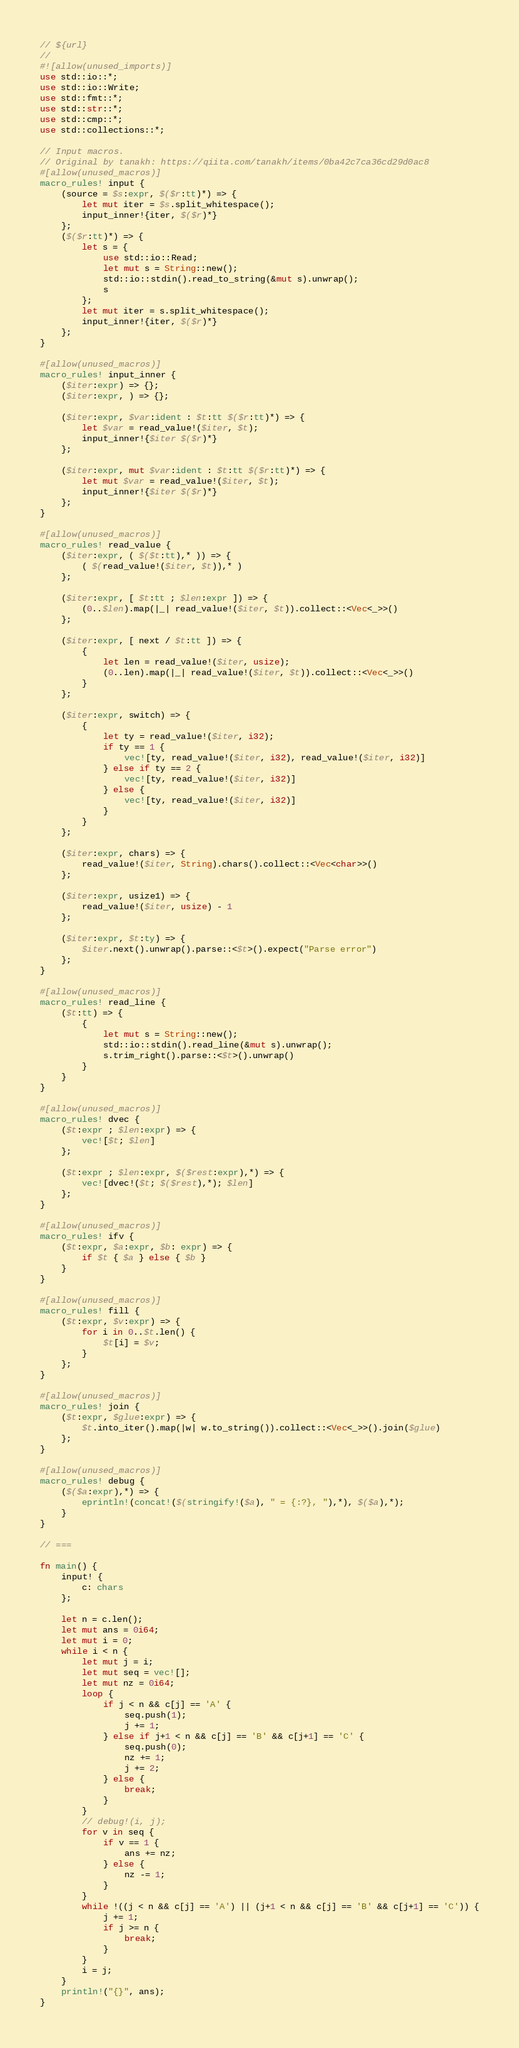<code> <loc_0><loc_0><loc_500><loc_500><_Rust_>// ${url}
//
#![allow(unused_imports)]
use std::io::*;
use std::io::Write;
use std::fmt::*;
use std::str::*;
use std::cmp::*;
use std::collections::*;

// Input macros.
// Original by tanakh: https://qiita.com/tanakh/items/0ba42c7ca36cd29d0ac8
#[allow(unused_macros)]
macro_rules! input {
    (source = $s:expr, $($r:tt)*) => {
        let mut iter = $s.split_whitespace();
        input_inner!{iter, $($r)*}
    };
    ($($r:tt)*) => {
        let s = {
            use std::io::Read;
            let mut s = String::new();
            std::io::stdin().read_to_string(&mut s).unwrap();
            s
        };
        let mut iter = s.split_whitespace();
        input_inner!{iter, $($r)*}
    };
}

#[allow(unused_macros)]
macro_rules! input_inner {
    ($iter:expr) => {};
    ($iter:expr, ) => {};

    ($iter:expr, $var:ident : $t:tt $($r:tt)*) => {
        let $var = read_value!($iter, $t);
        input_inner!{$iter $($r)*}
    };

    ($iter:expr, mut $var:ident : $t:tt $($r:tt)*) => {
        let mut $var = read_value!($iter, $t);
        input_inner!{$iter $($r)*}
    };
}

#[allow(unused_macros)]
macro_rules! read_value {
    ($iter:expr, ( $($t:tt),* )) => {
        ( $(read_value!($iter, $t)),* )
    };

    ($iter:expr, [ $t:tt ; $len:expr ]) => {
        (0..$len).map(|_| read_value!($iter, $t)).collect::<Vec<_>>()
    };

    ($iter:expr, [ next / $t:tt ]) => {
        {
            let len = read_value!($iter, usize);
            (0..len).map(|_| read_value!($iter, $t)).collect::<Vec<_>>()
        }
    };

    ($iter:expr, switch) => {
        {
            let ty = read_value!($iter, i32);
            if ty == 1 {
                vec![ty, read_value!($iter, i32), read_value!($iter, i32)]
            } else if ty == 2 {
                vec![ty, read_value!($iter, i32)]
            } else {
                vec![ty, read_value!($iter, i32)]
            }
        }
    };

    ($iter:expr, chars) => {
        read_value!($iter, String).chars().collect::<Vec<char>>()
    };

    ($iter:expr, usize1) => {
        read_value!($iter, usize) - 1
    };

    ($iter:expr, $t:ty) => {
        $iter.next().unwrap().parse::<$t>().expect("Parse error")
    };
}

#[allow(unused_macros)]
macro_rules! read_line {
    ($t:tt) => {
        {
            let mut s = String::new();
            std::io::stdin().read_line(&mut s).unwrap();
            s.trim_right().parse::<$t>().unwrap()
        }
    }
}

#[allow(unused_macros)]
macro_rules! dvec {
    ($t:expr ; $len:expr) => {
        vec![$t; $len]
    };

    ($t:expr ; $len:expr, $($rest:expr),*) => {
        vec![dvec!($t; $($rest),*); $len]
    };
}

#[allow(unused_macros)]
macro_rules! ifv {
    ($t:expr, $a:expr, $b: expr) => {
        if $t { $a } else { $b }
    }
}

#[allow(unused_macros)]
macro_rules! fill {
    ($t:expr, $v:expr) => {
        for i in 0..$t.len() {
            $t[i] = $v;
        }
    };
}

#[allow(unused_macros)]
macro_rules! join {
    ($t:expr, $glue:expr) => {
        $t.into_iter().map(|w| w.to_string()).collect::<Vec<_>>().join($glue)
    };
}

#[allow(unused_macros)]
macro_rules! debug {
    ($($a:expr),*) => {
        eprintln!(concat!($(stringify!($a), " = {:?}, "),*), $($a),*);
    }
}

// ===

fn main() {
    input! {
        c: chars
    };

    let n = c.len();
    let mut ans = 0i64;
    let mut i = 0;
    while i < n {
        let mut j = i;
        let mut seq = vec![];
        let mut nz = 0i64;
        loop {
            if j < n && c[j] == 'A' {
                seq.push(1);
                j += 1;
            } else if j+1 < n && c[j] == 'B' && c[j+1] == 'C' {
                seq.push(0);
                nz += 1;
                j += 2;
            } else {
                break;
            }
        }
        // debug!(i, j);
        for v in seq {
            if v == 1 {
                ans += nz;
            } else {
                nz -= 1;
            }
        }
        while !((j < n && c[j] == 'A') || (j+1 < n && c[j] == 'B' && c[j+1] == 'C')) {
            j += 1;
            if j >= n {
                break;
            }
        }
        i = j;
    }
    println!("{}", ans);
}
</code> 